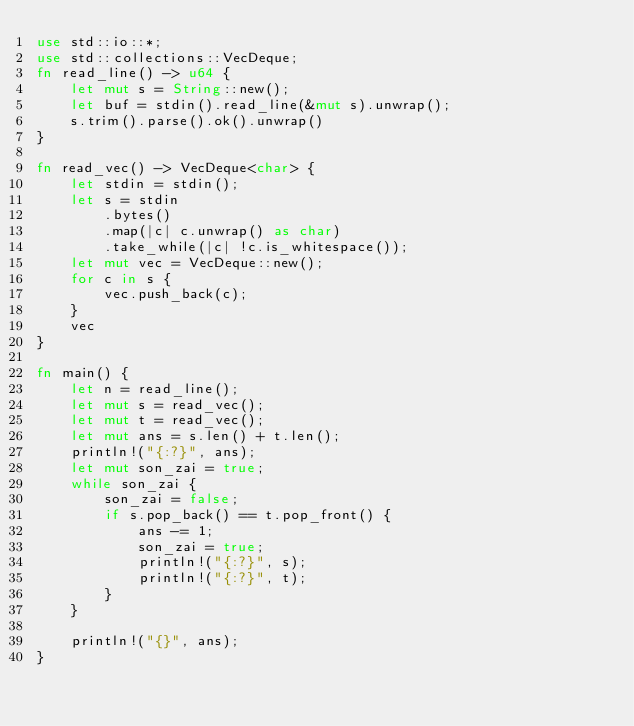Convert code to text. <code><loc_0><loc_0><loc_500><loc_500><_Rust_>use std::io::*;
use std::collections::VecDeque;
fn read_line() -> u64 {
    let mut s = String::new();
    let buf = stdin().read_line(&mut s).unwrap();
    s.trim().parse().ok().unwrap()
}

fn read_vec() -> VecDeque<char> {
    let stdin = stdin();
    let s = stdin
        .bytes()
        .map(|c| c.unwrap() as char)
        .take_while(|c| !c.is_whitespace());
    let mut vec = VecDeque::new();
    for c in s {
        vec.push_back(c);
    }
    vec
}

fn main() {
    let n = read_line();
    let mut s = read_vec();
    let mut t = read_vec();
    let mut ans = s.len() + t.len();
    println!("{:?}", ans);
    let mut son_zai = true;
    while son_zai {
        son_zai = false;
        if s.pop_back() == t.pop_front() {
            ans -= 1;
            son_zai = true;
            println!("{:?}", s);
            println!("{:?}", t);
        }
    }

    println!("{}", ans);
}
</code> 